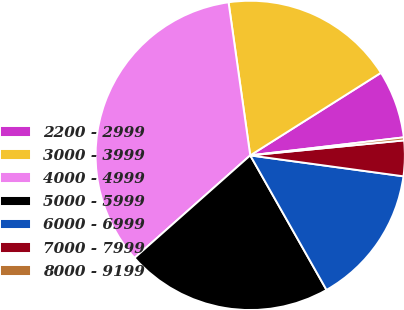Convert chart. <chart><loc_0><loc_0><loc_500><loc_500><pie_chart><fcel>2200 - 2999<fcel>3000 - 3999<fcel>4000 - 4999<fcel>5000 - 5999<fcel>6000 - 6999<fcel>7000 - 7999<fcel>8000 - 9199<nl><fcel>7.11%<fcel>18.27%<fcel>34.3%<fcel>21.67%<fcel>14.63%<fcel>3.71%<fcel>0.31%<nl></chart> 